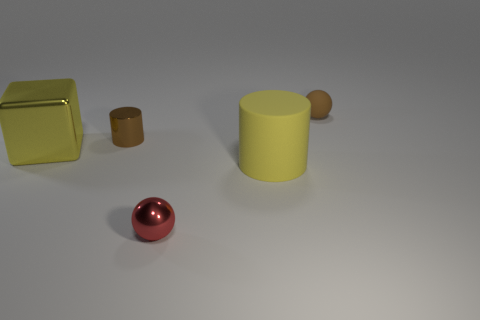Subtract all cylinders. How many objects are left? 3 Subtract 1 balls. How many balls are left? 1 Add 5 tiny blue rubber things. How many objects exist? 10 Subtract 1 brown cylinders. How many objects are left? 4 Subtract all brown cylinders. Subtract all green cubes. How many cylinders are left? 1 Subtract all green cylinders. How many cyan cubes are left? 0 Subtract all red metallic balls. Subtract all brown cylinders. How many objects are left? 3 Add 4 red shiny things. How many red shiny things are left? 5 Add 5 yellow shiny objects. How many yellow shiny objects exist? 6 